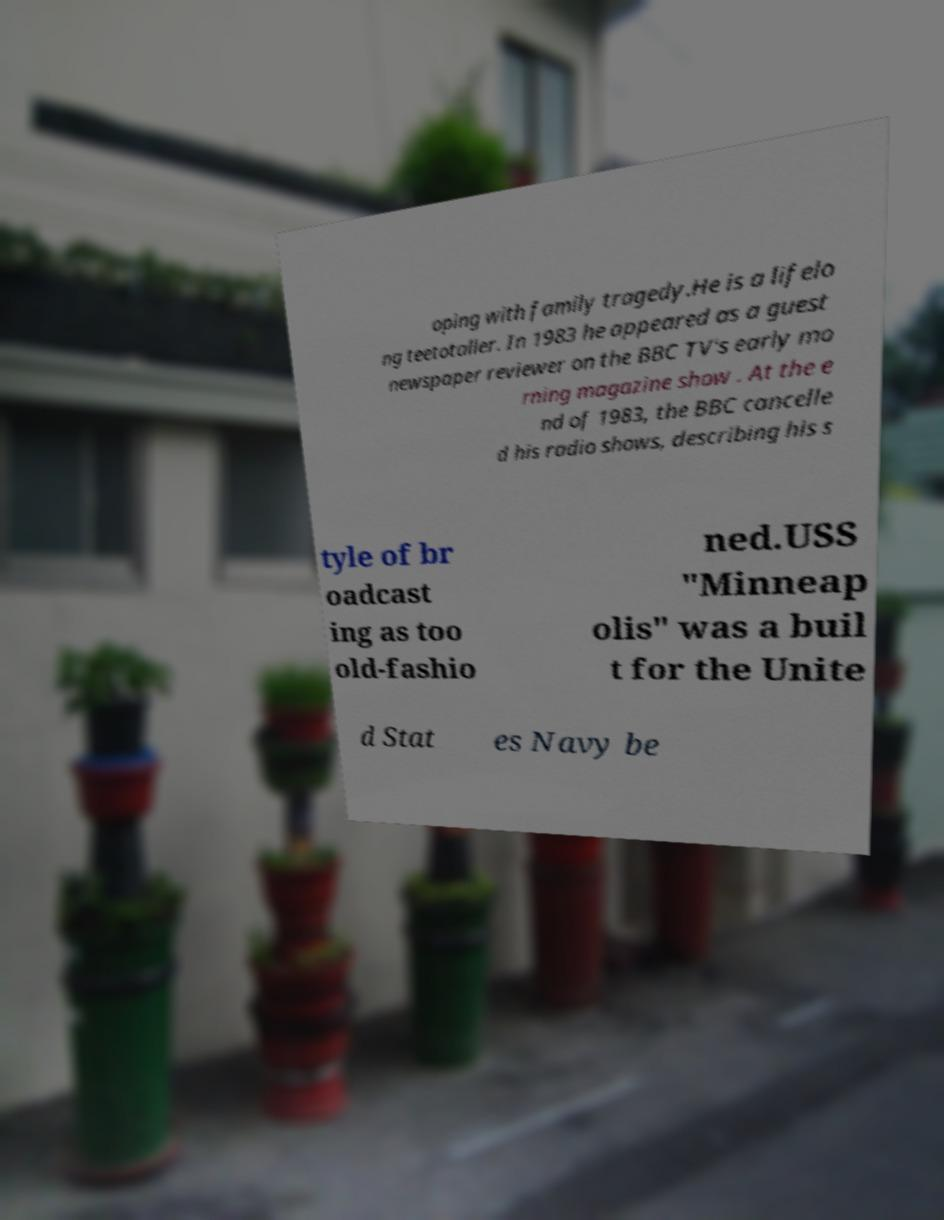Please identify and transcribe the text found in this image. oping with family tragedy.He is a lifelo ng teetotaller. In 1983 he appeared as a guest newspaper reviewer on the BBC TV's early mo rning magazine show . At the e nd of 1983, the BBC cancelle d his radio shows, describing his s tyle of br oadcast ing as too old-fashio ned.USS "Minneap olis" was a buil t for the Unite d Stat es Navy be 